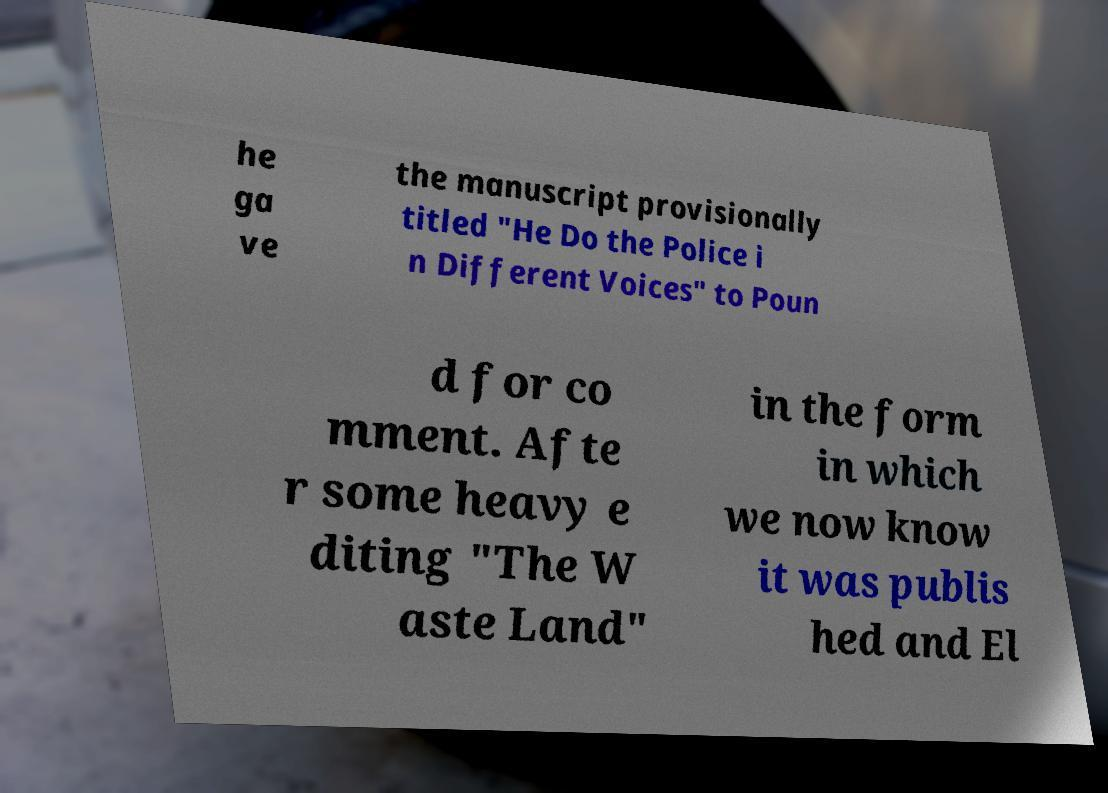There's text embedded in this image that I need extracted. Can you transcribe it verbatim? he ga ve the manuscript provisionally titled "He Do the Police i n Different Voices" to Poun d for co mment. Afte r some heavy e diting "The W aste Land" in the form in which we now know it was publis hed and El 